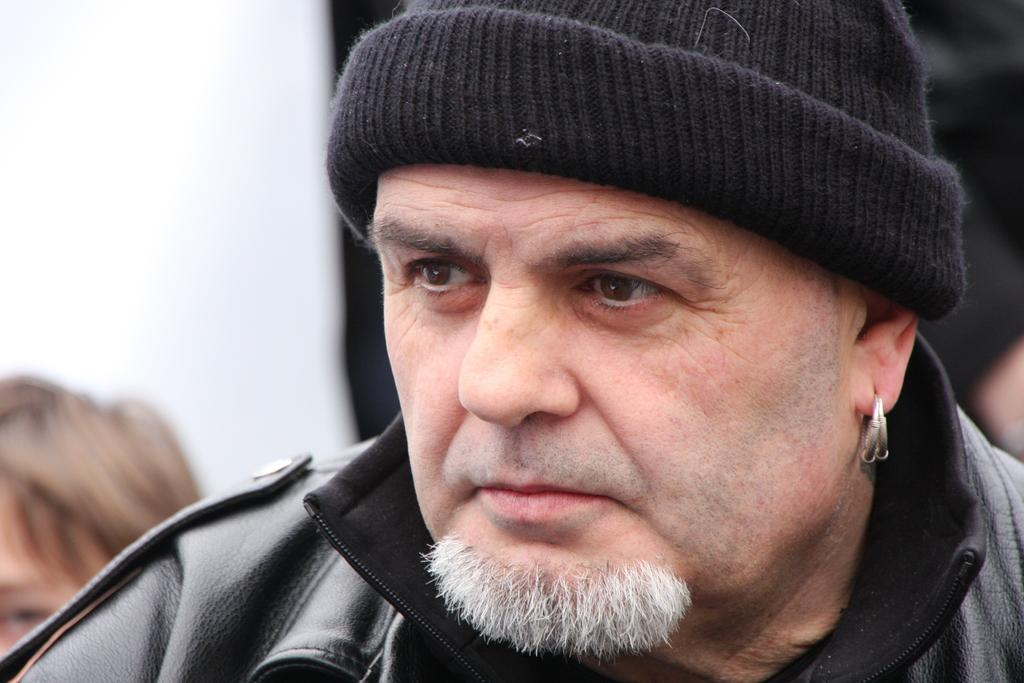Who is the main subject in the image? There is a person in the image. What is the person wearing on their upper body? The person is wearing a black jacket. What type of headwear is the person wearing? The person is wearing a cap. Are there any other people visible in the image? Yes, there are other persons visible behind the main person. What type of produce is being held by the person in the image? There is no produce visible in the image; the person is wearing a black jacket and cap. What type of beverage is being served in the image? There is no beverage visible in the image; the focus is on the person and their clothing. 